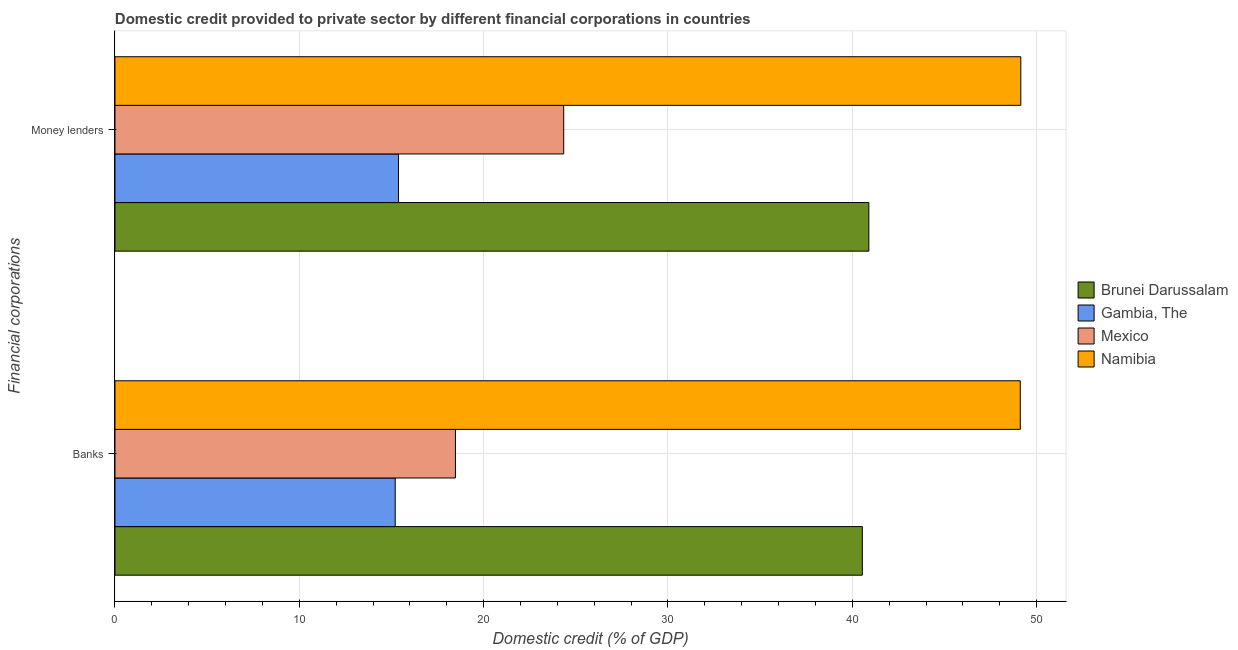How many different coloured bars are there?
Provide a succinct answer. 4. How many groups of bars are there?
Your answer should be very brief. 2. Are the number of bars on each tick of the Y-axis equal?
Your response must be concise. Yes. How many bars are there on the 1st tick from the bottom?
Your response must be concise. 4. What is the label of the 1st group of bars from the top?
Provide a short and direct response. Money lenders. What is the domestic credit provided by money lenders in Mexico?
Give a very brief answer. 24.34. Across all countries, what is the maximum domestic credit provided by banks?
Your answer should be compact. 49.11. Across all countries, what is the minimum domestic credit provided by banks?
Make the answer very short. 15.2. In which country was the domestic credit provided by money lenders maximum?
Provide a short and direct response. Namibia. In which country was the domestic credit provided by banks minimum?
Make the answer very short. Gambia, The. What is the total domestic credit provided by banks in the graph?
Provide a succinct answer. 123.33. What is the difference between the domestic credit provided by money lenders in Namibia and that in Gambia, The?
Your response must be concise. 33.76. What is the difference between the domestic credit provided by banks in Namibia and the domestic credit provided by money lenders in Brunei Darussalam?
Offer a terse response. 8.22. What is the average domestic credit provided by money lenders per country?
Offer a very short reply. 32.44. What is the difference between the domestic credit provided by money lenders and domestic credit provided by banks in Namibia?
Offer a very short reply. 0.03. In how many countries, is the domestic credit provided by money lenders greater than 24 %?
Offer a very short reply. 3. What is the ratio of the domestic credit provided by banks in Brunei Darussalam to that in Mexico?
Offer a terse response. 2.2. Is the domestic credit provided by banks in Gambia, The less than that in Brunei Darussalam?
Keep it short and to the point. Yes. In how many countries, is the domestic credit provided by banks greater than the average domestic credit provided by banks taken over all countries?
Your answer should be very brief. 2. What does the 1st bar from the top in Money lenders represents?
Ensure brevity in your answer.  Namibia. Are all the bars in the graph horizontal?
Give a very brief answer. Yes. How many countries are there in the graph?
Make the answer very short. 4. What is the difference between two consecutive major ticks on the X-axis?
Offer a very short reply. 10. Does the graph contain any zero values?
Your answer should be compact. No. Where does the legend appear in the graph?
Provide a succinct answer. Center right. What is the title of the graph?
Your answer should be compact. Domestic credit provided to private sector by different financial corporations in countries. What is the label or title of the X-axis?
Give a very brief answer. Domestic credit (% of GDP). What is the label or title of the Y-axis?
Your answer should be compact. Financial corporations. What is the Domestic credit (% of GDP) of Brunei Darussalam in Banks?
Your answer should be compact. 40.54. What is the Domestic credit (% of GDP) in Gambia, The in Banks?
Give a very brief answer. 15.2. What is the Domestic credit (% of GDP) in Mexico in Banks?
Offer a terse response. 18.47. What is the Domestic credit (% of GDP) in Namibia in Banks?
Your answer should be very brief. 49.11. What is the Domestic credit (% of GDP) of Brunei Darussalam in Money lenders?
Provide a short and direct response. 40.9. What is the Domestic credit (% of GDP) of Gambia, The in Money lenders?
Provide a short and direct response. 15.38. What is the Domestic credit (% of GDP) of Mexico in Money lenders?
Keep it short and to the point. 24.34. What is the Domestic credit (% of GDP) of Namibia in Money lenders?
Your response must be concise. 49.14. Across all Financial corporations, what is the maximum Domestic credit (% of GDP) of Brunei Darussalam?
Offer a very short reply. 40.9. Across all Financial corporations, what is the maximum Domestic credit (% of GDP) in Gambia, The?
Offer a terse response. 15.38. Across all Financial corporations, what is the maximum Domestic credit (% of GDP) of Mexico?
Provide a succinct answer. 24.34. Across all Financial corporations, what is the maximum Domestic credit (% of GDP) of Namibia?
Keep it short and to the point. 49.14. Across all Financial corporations, what is the minimum Domestic credit (% of GDP) of Brunei Darussalam?
Offer a very short reply. 40.54. Across all Financial corporations, what is the minimum Domestic credit (% of GDP) of Gambia, The?
Your response must be concise. 15.2. Across all Financial corporations, what is the minimum Domestic credit (% of GDP) in Mexico?
Provide a succinct answer. 18.47. Across all Financial corporations, what is the minimum Domestic credit (% of GDP) of Namibia?
Offer a very short reply. 49.11. What is the total Domestic credit (% of GDP) of Brunei Darussalam in the graph?
Offer a very short reply. 81.44. What is the total Domestic credit (% of GDP) of Gambia, The in the graph?
Offer a very short reply. 30.58. What is the total Domestic credit (% of GDP) in Mexico in the graph?
Make the answer very short. 42.81. What is the total Domestic credit (% of GDP) of Namibia in the graph?
Your answer should be very brief. 98.25. What is the difference between the Domestic credit (% of GDP) in Brunei Darussalam in Banks and that in Money lenders?
Your answer should be compact. -0.35. What is the difference between the Domestic credit (% of GDP) of Gambia, The in Banks and that in Money lenders?
Ensure brevity in your answer.  -0.18. What is the difference between the Domestic credit (% of GDP) in Mexico in Banks and that in Money lenders?
Keep it short and to the point. -5.87. What is the difference between the Domestic credit (% of GDP) of Namibia in Banks and that in Money lenders?
Your answer should be very brief. -0.03. What is the difference between the Domestic credit (% of GDP) in Brunei Darussalam in Banks and the Domestic credit (% of GDP) in Gambia, The in Money lenders?
Your response must be concise. 25.16. What is the difference between the Domestic credit (% of GDP) of Brunei Darussalam in Banks and the Domestic credit (% of GDP) of Mexico in Money lenders?
Make the answer very short. 16.2. What is the difference between the Domestic credit (% of GDP) in Brunei Darussalam in Banks and the Domestic credit (% of GDP) in Namibia in Money lenders?
Ensure brevity in your answer.  -8.6. What is the difference between the Domestic credit (% of GDP) in Gambia, The in Banks and the Domestic credit (% of GDP) in Mexico in Money lenders?
Offer a terse response. -9.14. What is the difference between the Domestic credit (% of GDP) in Gambia, The in Banks and the Domestic credit (% of GDP) in Namibia in Money lenders?
Offer a very short reply. -33.94. What is the difference between the Domestic credit (% of GDP) in Mexico in Banks and the Domestic credit (% of GDP) in Namibia in Money lenders?
Ensure brevity in your answer.  -30.67. What is the average Domestic credit (% of GDP) of Brunei Darussalam per Financial corporations?
Offer a very short reply. 40.72. What is the average Domestic credit (% of GDP) of Gambia, The per Financial corporations?
Your answer should be compact. 15.29. What is the average Domestic credit (% of GDP) in Mexico per Financial corporations?
Your answer should be very brief. 21.41. What is the average Domestic credit (% of GDP) in Namibia per Financial corporations?
Provide a succinct answer. 49.13. What is the difference between the Domestic credit (% of GDP) in Brunei Darussalam and Domestic credit (% of GDP) in Gambia, The in Banks?
Offer a very short reply. 25.34. What is the difference between the Domestic credit (% of GDP) in Brunei Darussalam and Domestic credit (% of GDP) in Mexico in Banks?
Make the answer very short. 22.07. What is the difference between the Domestic credit (% of GDP) of Brunei Darussalam and Domestic credit (% of GDP) of Namibia in Banks?
Your response must be concise. -8.57. What is the difference between the Domestic credit (% of GDP) of Gambia, The and Domestic credit (% of GDP) of Mexico in Banks?
Make the answer very short. -3.27. What is the difference between the Domestic credit (% of GDP) of Gambia, The and Domestic credit (% of GDP) of Namibia in Banks?
Offer a terse response. -33.91. What is the difference between the Domestic credit (% of GDP) of Mexico and Domestic credit (% of GDP) of Namibia in Banks?
Ensure brevity in your answer.  -30.64. What is the difference between the Domestic credit (% of GDP) of Brunei Darussalam and Domestic credit (% of GDP) of Gambia, The in Money lenders?
Ensure brevity in your answer.  25.52. What is the difference between the Domestic credit (% of GDP) in Brunei Darussalam and Domestic credit (% of GDP) in Mexico in Money lenders?
Give a very brief answer. 16.55. What is the difference between the Domestic credit (% of GDP) in Brunei Darussalam and Domestic credit (% of GDP) in Namibia in Money lenders?
Your answer should be compact. -8.24. What is the difference between the Domestic credit (% of GDP) in Gambia, The and Domestic credit (% of GDP) in Mexico in Money lenders?
Make the answer very short. -8.96. What is the difference between the Domestic credit (% of GDP) of Gambia, The and Domestic credit (% of GDP) of Namibia in Money lenders?
Make the answer very short. -33.76. What is the difference between the Domestic credit (% of GDP) in Mexico and Domestic credit (% of GDP) in Namibia in Money lenders?
Provide a succinct answer. -24.8. What is the ratio of the Domestic credit (% of GDP) of Mexico in Banks to that in Money lenders?
Offer a terse response. 0.76. What is the difference between the highest and the second highest Domestic credit (% of GDP) in Brunei Darussalam?
Your response must be concise. 0.35. What is the difference between the highest and the second highest Domestic credit (% of GDP) in Gambia, The?
Keep it short and to the point. 0.18. What is the difference between the highest and the second highest Domestic credit (% of GDP) of Mexico?
Make the answer very short. 5.87. What is the difference between the highest and the second highest Domestic credit (% of GDP) in Namibia?
Make the answer very short. 0.03. What is the difference between the highest and the lowest Domestic credit (% of GDP) in Brunei Darussalam?
Make the answer very short. 0.35. What is the difference between the highest and the lowest Domestic credit (% of GDP) in Gambia, The?
Provide a succinct answer. 0.18. What is the difference between the highest and the lowest Domestic credit (% of GDP) of Mexico?
Make the answer very short. 5.87. What is the difference between the highest and the lowest Domestic credit (% of GDP) of Namibia?
Ensure brevity in your answer.  0.03. 